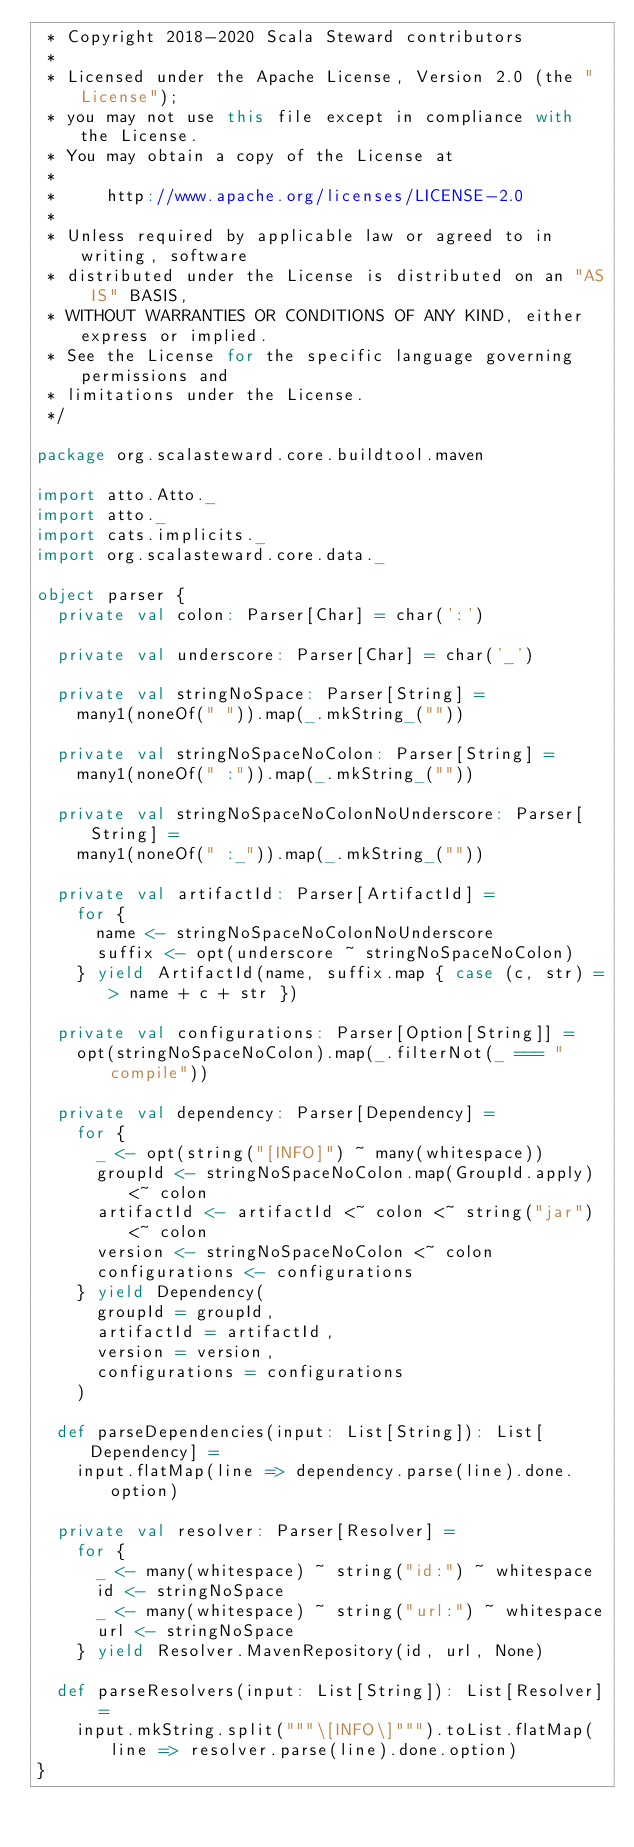<code> <loc_0><loc_0><loc_500><loc_500><_Scala_> * Copyright 2018-2020 Scala Steward contributors
 *
 * Licensed under the Apache License, Version 2.0 (the "License");
 * you may not use this file except in compliance with the License.
 * You may obtain a copy of the License at
 *
 *     http://www.apache.org/licenses/LICENSE-2.0
 *
 * Unless required by applicable law or agreed to in writing, software
 * distributed under the License is distributed on an "AS IS" BASIS,
 * WITHOUT WARRANTIES OR CONDITIONS OF ANY KIND, either express or implied.
 * See the License for the specific language governing permissions and
 * limitations under the License.
 */

package org.scalasteward.core.buildtool.maven

import atto.Atto._
import atto._
import cats.implicits._
import org.scalasteward.core.data._

object parser {
  private val colon: Parser[Char] = char(':')

  private val underscore: Parser[Char] = char('_')

  private val stringNoSpace: Parser[String] =
    many1(noneOf(" ")).map(_.mkString_(""))

  private val stringNoSpaceNoColon: Parser[String] =
    many1(noneOf(" :")).map(_.mkString_(""))

  private val stringNoSpaceNoColonNoUnderscore: Parser[String] =
    many1(noneOf(" :_")).map(_.mkString_(""))

  private val artifactId: Parser[ArtifactId] =
    for {
      name <- stringNoSpaceNoColonNoUnderscore
      suffix <- opt(underscore ~ stringNoSpaceNoColon)
    } yield ArtifactId(name, suffix.map { case (c, str) => name + c + str })

  private val configurations: Parser[Option[String]] =
    opt(stringNoSpaceNoColon).map(_.filterNot(_ === "compile"))

  private val dependency: Parser[Dependency] =
    for {
      _ <- opt(string("[INFO]") ~ many(whitespace))
      groupId <- stringNoSpaceNoColon.map(GroupId.apply) <~ colon
      artifactId <- artifactId <~ colon <~ string("jar") <~ colon
      version <- stringNoSpaceNoColon <~ colon
      configurations <- configurations
    } yield Dependency(
      groupId = groupId,
      artifactId = artifactId,
      version = version,
      configurations = configurations
    )

  def parseDependencies(input: List[String]): List[Dependency] =
    input.flatMap(line => dependency.parse(line).done.option)

  private val resolver: Parser[Resolver] =
    for {
      _ <- many(whitespace) ~ string("id:") ~ whitespace
      id <- stringNoSpace
      _ <- many(whitespace) ~ string("url:") ~ whitespace
      url <- stringNoSpace
    } yield Resolver.MavenRepository(id, url, None)

  def parseResolvers(input: List[String]): List[Resolver] =
    input.mkString.split("""\[INFO\]""").toList.flatMap(line => resolver.parse(line).done.option)
}
</code> 